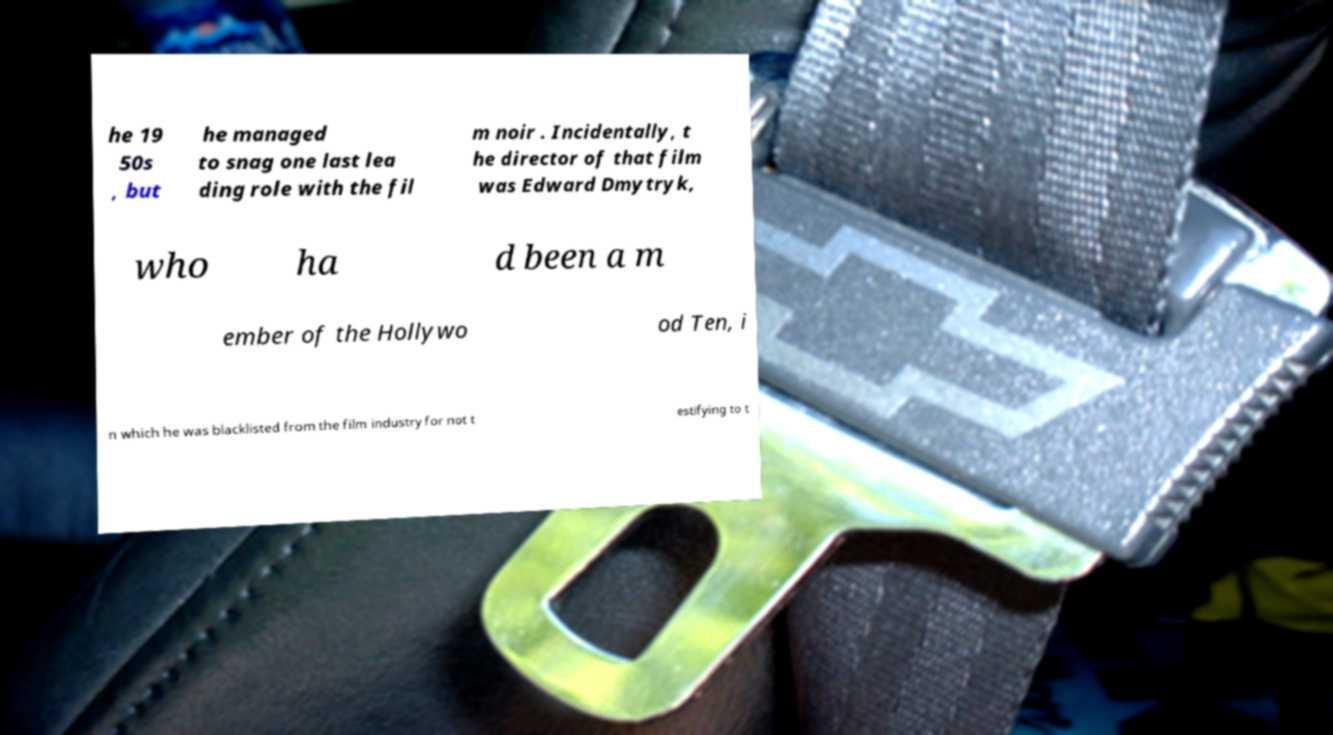What messages or text are displayed in this image? I need them in a readable, typed format. he 19 50s , but he managed to snag one last lea ding role with the fil m noir . Incidentally, t he director of that film was Edward Dmytryk, who ha d been a m ember of the Hollywo od Ten, i n which he was blacklisted from the film industry for not t estifying to t 